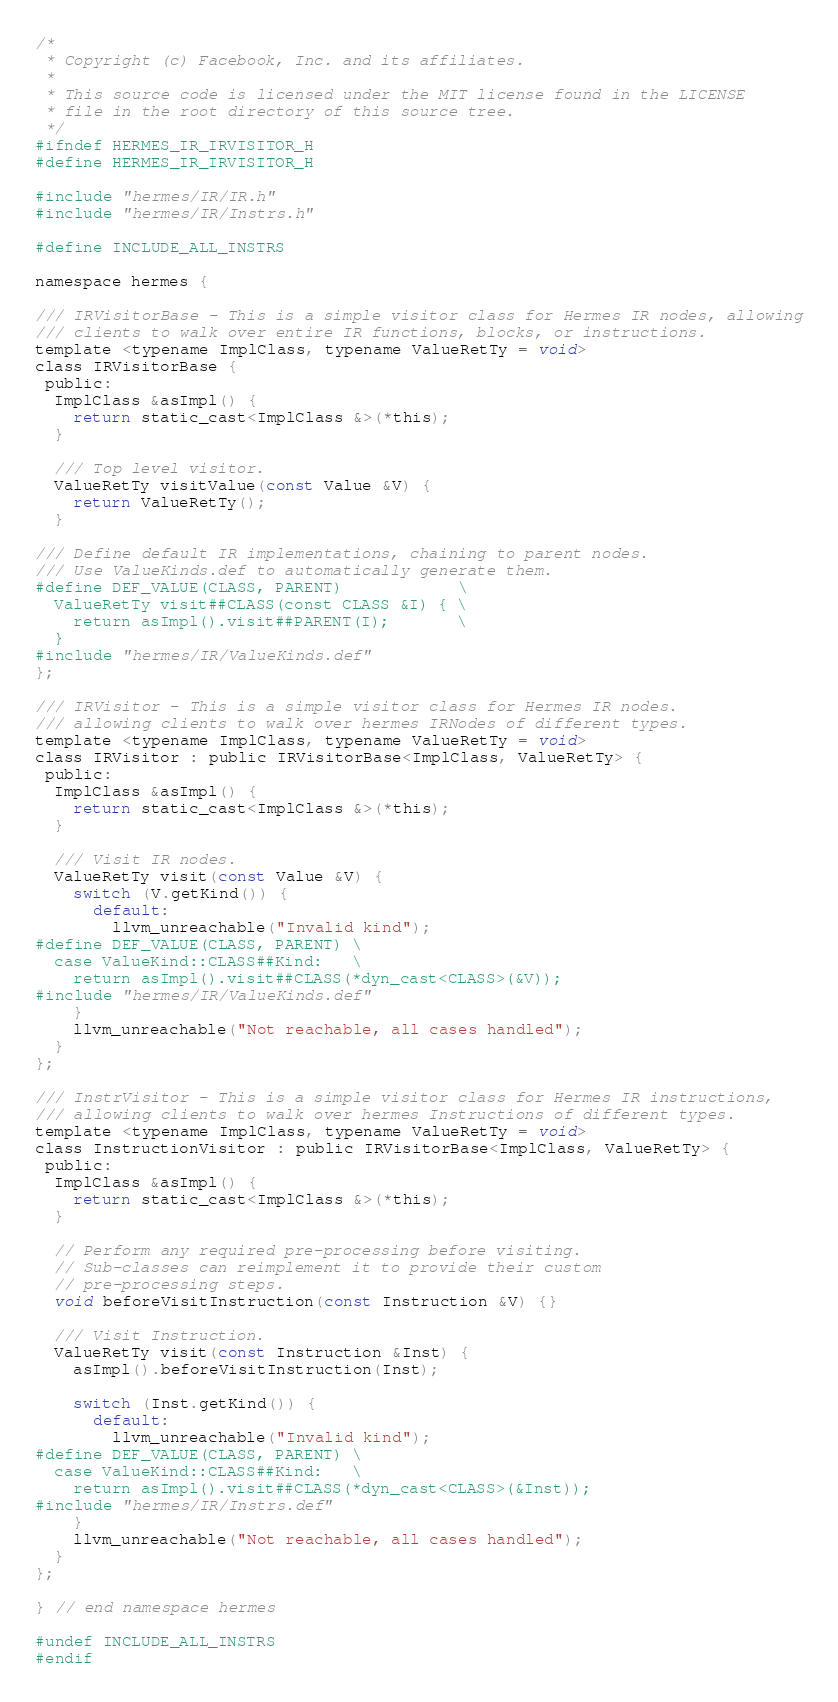<code> <loc_0><loc_0><loc_500><loc_500><_C_>/*
 * Copyright (c) Facebook, Inc. and its affiliates.
 *
 * This source code is licensed under the MIT license found in the LICENSE
 * file in the root directory of this source tree.
 */
#ifndef HERMES_IR_IRVISITOR_H
#define HERMES_IR_IRVISITOR_H

#include "hermes/IR/IR.h"
#include "hermes/IR/Instrs.h"

#define INCLUDE_ALL_INSTRS

namespace hermes {

/// IRVisitorBase - This is a simple visitor class for Hermes IR nodes, allowing
/// clients to walk over entire IR functions, blocks, or instructions.
template <typename ImplClass, typename ValueRetTy = void>
class IRVisitorBase {
 public:
  ImplClass &asImpl() {
    return static_cast<ImplClass &>(*this);
  }

  /// Top level visitor.
  ValueRetTy visitValue(const Value &V) {
    return ValueRetTy();
  }

/// Define default IR implementations, chaining to parent nodes.
/// Use ValueKinds.def to automatically generate them.
#define DEF_VALUE(CLASS, PARENT)            \
  ValueRetTy visit##CLASS(const CLASS &I) { \
    return asImpl().visit##PARENT(I);       \
  }
#include "hermes/IR/ValueKinds.def"
};

/// IRVisitor - This is a simple visitor class for Hermes IR nodes.
/// allowing clients to walk over hermes IRNodes of different types.
template <typename ImplClass, typename ValueRetTy = void>
class IRVisitor : public IRVisitorBase<ImplClass, ValueRetTy> {
 public:
  ImplClass &asImpl() {
    return static_cast<ImplClass &>(*this);
  }

  /// Visit IR nodes.
  ValueRetTy visit(const Value &V) {
    switch (V.getKind()) {
      default:
        llvm_unreachable("Invalid kind");
#define DEF_VALUE(CLASS, PARENT) \
  case ValueKind::CLASS##Kind:   \
    return asImpl().visit##CLASS(*dyn_cast<CLASS>(&V));
#include "hermes/IR/ValueKinds.def"
    }
    llvm_unreachable("Not reachable, all cases handled");
  }
};

/// InstrVisitor - This is a simple visitor class for Hermes IR instructions,
/// allowing clients to walk over hermes Instructions of different types.
template <typename ImplClass, typename ValueRetTy = void>
class InstructionVisitor : public IRVisitorBase<ImplClass, ValueRetTy> {
 public:
  ImplClass &asImpl() {
    return static_cast<ImplClass &>(*this);
  }

  // Perform any required pre-processing before visiting.
  // Sub-classes can reimplement it to provide their custom
  // pre-processing steps.
  void beforeVisitInstruction(const Instruction &V) {}

  /// Visit Instruction.
  ValueRetTy visit(const Instruction &Inst) {
    asImpl().beforeVisitInstruction(Inst);

    switch (Inst.getKind()) {
      default:
        llvm_unreachable("Invalid kind");
#define DEF_VALUE(CLASS, PARENT) \
  case ValueKind::CLASS##Kind:   \
    return asImpl().visit##CLASS(*dyn_cast<CLASS>(&Inst));
#include "hermes/IR/Instrs.def"
    }
    llvm_unreachable("Not reachable, all cases handled");
  }
};

} // end namespace hermes

#undef INCLUDE_ALL_INSTRS
#endif
</code> 